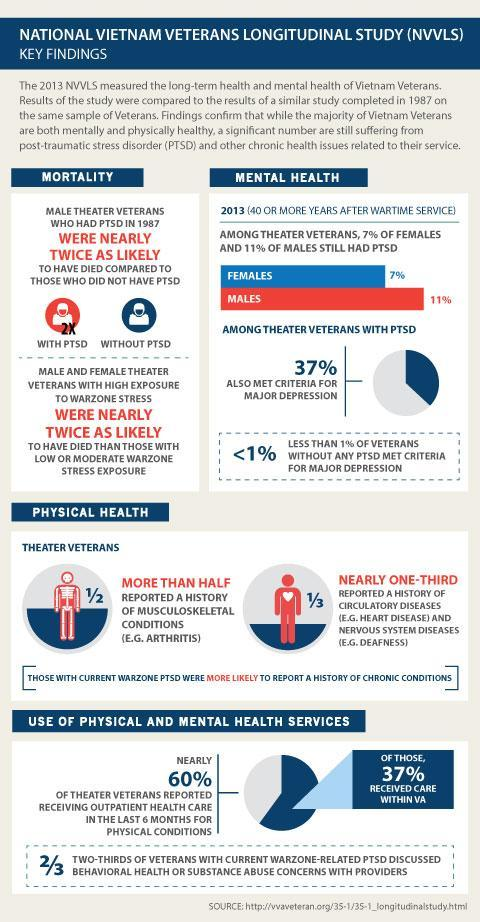What percent of the theatre veterans received outpatient health care over the last six months?
Answer the question with a short phrase. 60% Among whom is the mortality higher, those with PTSD or those without PTSD? Those with PTSD Out of every 3 veterans, how many discussed their health concerns with providers? 2 Name a musculoskeletal disease seen in theatre veterans? Arthritis What percent of the theatre veterans reported history of musculoskeletal conditions(approx)? 50% What percent of the theatre veterans with PTSD also met criteria for Major depression? 37% Name a common nervous system disease seen among theatre veterans? Deafness Out of every 3 veterans, how many have a history of circulatory diseases and nervous system diseases? 1 What percent of theatre veterans without PTSD met criterion for Major depression? <1% What percent of the veterans received care within the VA? 37% 